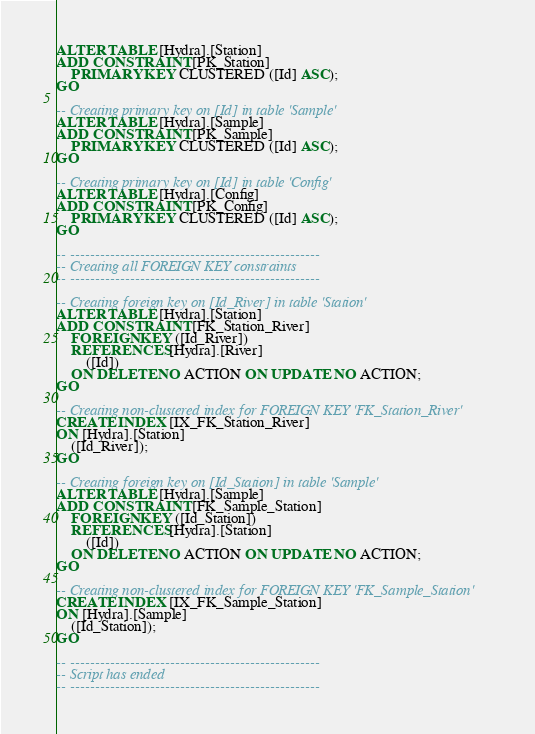<code> <loc_0><loc_0><loc_500><loc_500><_SQL_>ALTER TABLE [Hydra].[Station]
ADD CONSTRAINT [PK_Station]
    PRIMARY KEY CLUSTERED ([Id] ASC);
GO

-- Creating primary key on [Id] in table 'Sample'
ALTER TABLE [Hydra].[Sample]
ADD CONSTRAINT [PK_Sample]
    PRIMARY KEY CLUSTERED ([Id] ASC);
GO

-- Creating primary key on [Id] in table 'Config'
ALTER TABLE [Hydra].[Config]
ADD CONSTRAINT [PK_Config]
    PRIMARY KEY CLUSTERED ([Id] ASC);
GO

-- --------------------------------------------------
-- Creating all FOREIGN KEY constraints
-- --------------------------------------------------

-- Creating foreign key on [Id_River] in table 'Station'
ALTER TABLE [Hydra].[Station]
ADD CONSTRAINT [FK_Station_River]
    FOREIGN KEY ([Id_River])
    REFERENCES [Hydra].[River]
        ([Id])
    ON DELETE NO ACTION ON UPDATE NO ACTION;
GO

-- Creating non-clustered index for FOREIGN KEY 'FK_Station_River'
CREATE INDEX [IX_FK_Station_River]
ON [Hydra].[Station]
    ([Id_River]);
GO

-- Creating foreign key on [Id_Station] in table 'Sample'
ALTER TABLE [Hydra].[Sample]
ADD CONSTRAINT [FK_Sample_Station]
    FOREIGN KEY ([Id_Station])
    REFERENCES [Hydra].[Station]
        ([Id])
    ON DELETE NO ACTION ON UPDATE NO ACTION;
GO

-- Creating non-clustered index for FOREIGN KEY 'FK_Sample_Station'
CREATE INDEX [IX_FK_Sample_Station]
ON [Hydra].[Sample]
    ([Id_Station]);
GO

-- --------------------------------------------------
-- Script has ended
-- --------------------------------------------------</code> 